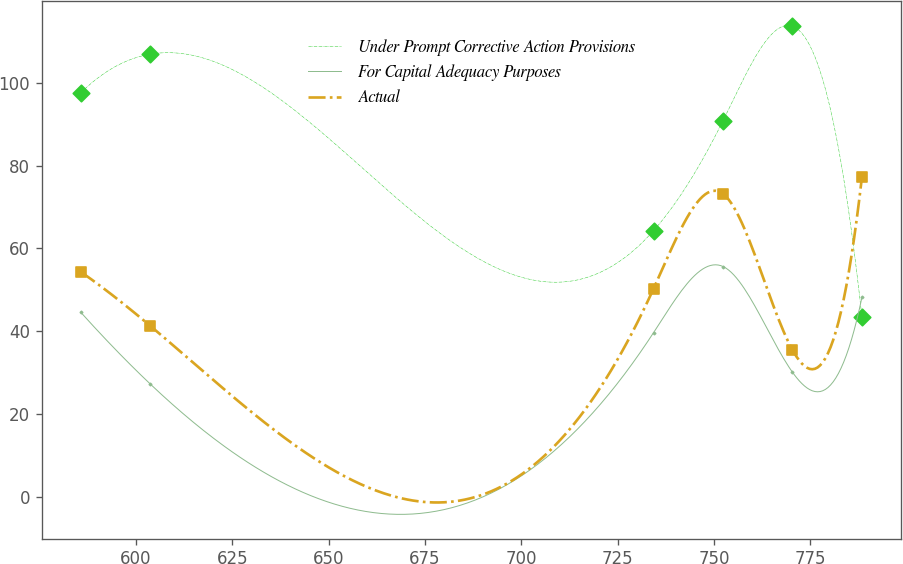Convert chart to OTSL. <chart><loc_0><loc_0><loc_500><loc_500><line_chart><ecel><fcel>Under Prompt Corrective Action Provisions<fcel>For Capital Adequacy Purposes<fcel>Actual<nl><fcel>585.7<fcel>97.58<fcel>44.57<fcel>54.33<nl><fcel>603.72<fcel>106.91<fcel>27.26<fcel>41.3<nl><fcel>734.31<fcel>64.29<fcel>39.66<fcel>50.29<nl><fcel>752.33<fcel>90.84<fcel>55.63<fcel>73.19<nl><fcel>770.35<fcel>113.65<fcel>30.1<fcel>35.49<nl><fcel>788.37<fcel>43.48<fcel>48.17<fcel>77.23<nl></chart> 